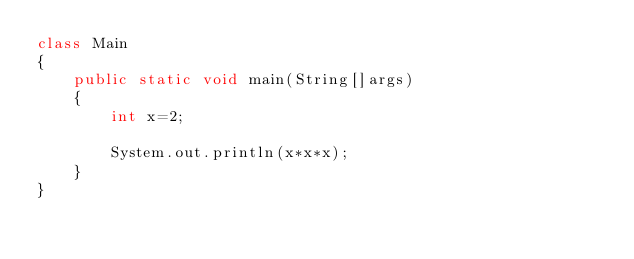<code> <loc_0><loc_0><loc_500><loc_500><_Java_>class Main
{
	public static void main(String[]args)
	{
		int x=2;
 
		System.out.println(x*x*x);
	}
}	</code> 